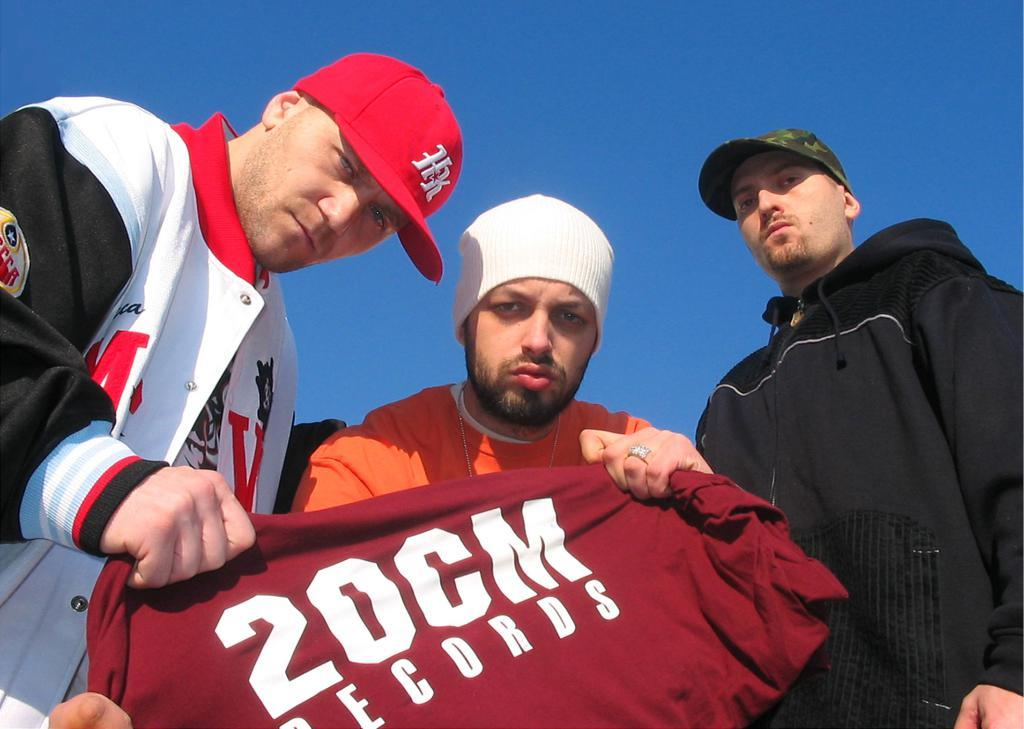<image>
Render a clear and concise summary of the photo. a shirt that says 20cm records on it 